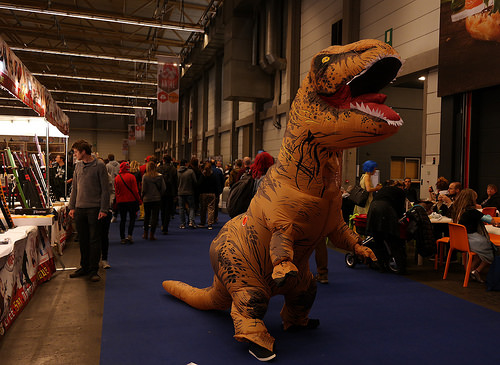<image>
Is there a blue carpet under the dino nose? Yes. The blue carpet is positioned underneath the dino nose, with the dino nose above it in the vertical space. Is there a dinosaur above the floor? No. The dinosaur is not positioned above the floor. The vertical arrangement shows a different relationship. 